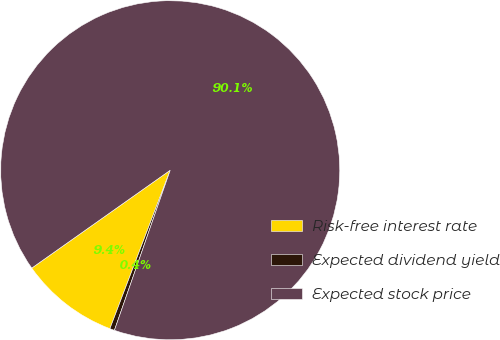Convert chart. <chart><loc_0><loc_0><loc_500><loc_500><pie_chart><fcel>Risk-free interest rate<fcel>Expected dividend yield<fcel>Expected stock price<nl><fcel>9.42%<fcel>0.45%<fcel>90.13%<nl></chart> 